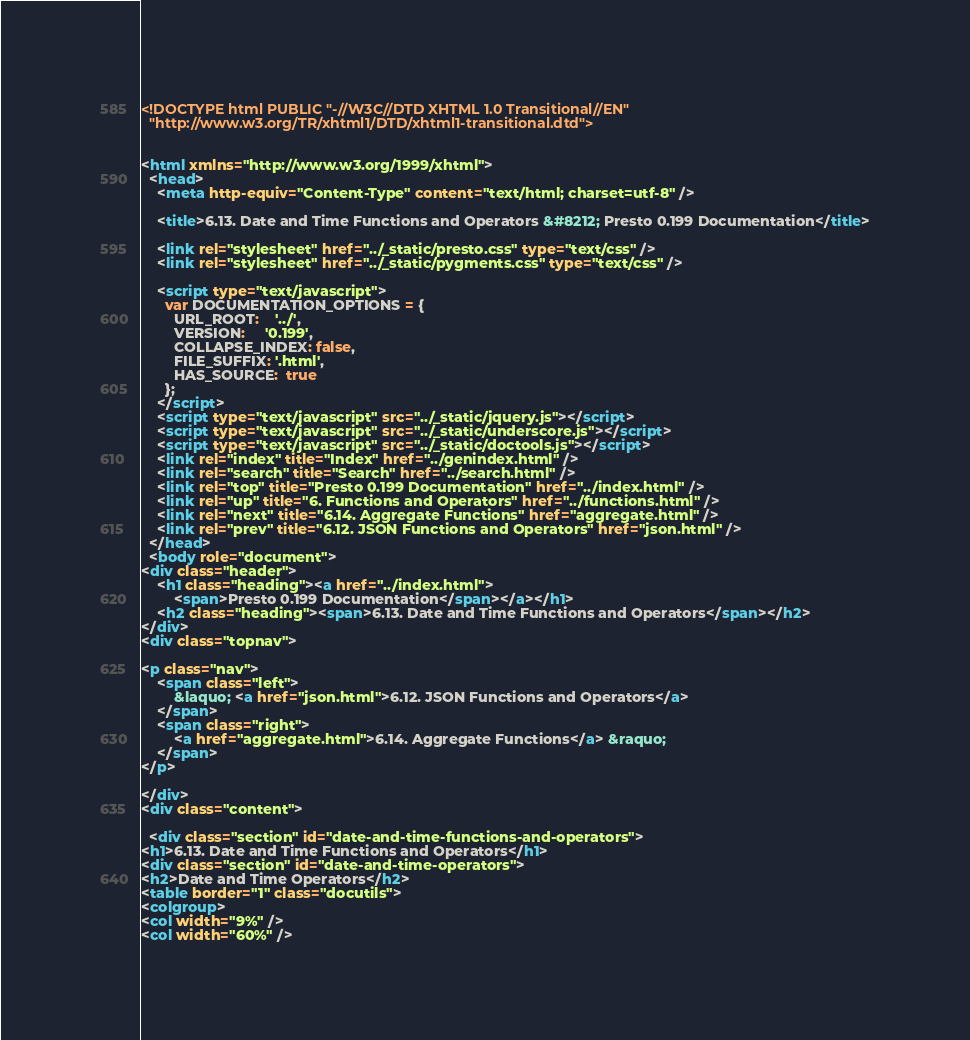<code> <loc_0><loc_0><loc_500><loc_500><_HTML_><!DOCTYPE html PUBLIC "-//W3C//DTD XHTML 1.0 Transitional//EN"
  "http://www.w3.org/TR/xhtml1/DTD/xhtml1-transitional.dtd">


<html xmlns="http://www.w3.org/1999/xhtml">
  <head>
    <meta http-equiv="Content-Type" content="text/html; charset=utf-8" />
    
    <title>6.13. Date and Time Functions and Operators &#8212; Presto 0.199 Documentation</title>
    
    <link rel="stylesheet" href="../_static/presto.css" type="text/css" />
    <link rel="stylesheet" href="../_static/pygments.css" type="text/css" />
    
    <script type="text/javascript">
      var DOCUMENTATION_OPTIONS = {
        URL_ROOT:    '../',
        VERSION:     '0.199',
        COLLAPSE_INDEX: false,
        FILE_SUFFIX: '.html',
        HAS_SOURCE:  true
      };
    </script>
    <script type="text/javascript" src="../_static/jquery.js"></script>
    <script type="text/javascript" src="../_static/underscore.js"></script>
    <script type="text/javascript" src="../_static/doctools.js"></script>
    <link rel="index" title="Index" href="../genindex.html" />
    <link rel="search" title="Search" href="../search.html" />
    <link rel="top" title="Presto 0.199 Documentation" href="../index.html" />
    <link rel="up" title="6. Functions and Operators" href="../functions.html" />
    <link rel="next" title="6.14. Aggregate Functions" href="aggregate.html" />
    <link rel="prev" title="6.12. JSON Functions and Operators" href="json.html" /> 
  </head>
  <body role="document">
<div class="header">
    <h1 class="heading"><a href="../index.html">
        <span>Presto 0.199 Documentation</span></a></h1>
    <h2 class="heading"><span>6.13. Date and Time Functions and Operators</span></h2>
</div>
<div class="topnav">
    
<p class="nav">
    <span class="left">
        &laquo; <a href="json.html">6.12. JSON Functions and Operators</a>
    </span>
    <span class="right">
        <a href="aggregate.html">6.14. Aggregate Functions</a> &raquo;
    </span>
</p>

</div>
<div class="content">
    
  <div class="section" id="date-and-time-functions-and-operators">
<h1>6.13. Date and Time Functions and Operators</h1>
<div class="section" id="date-and-time-operators">
<h2>Date and Time Operators</h2>
<table border="1" class="docutils">
<colgroup>
<col width="9%" />
<col width="60%" /></code> 